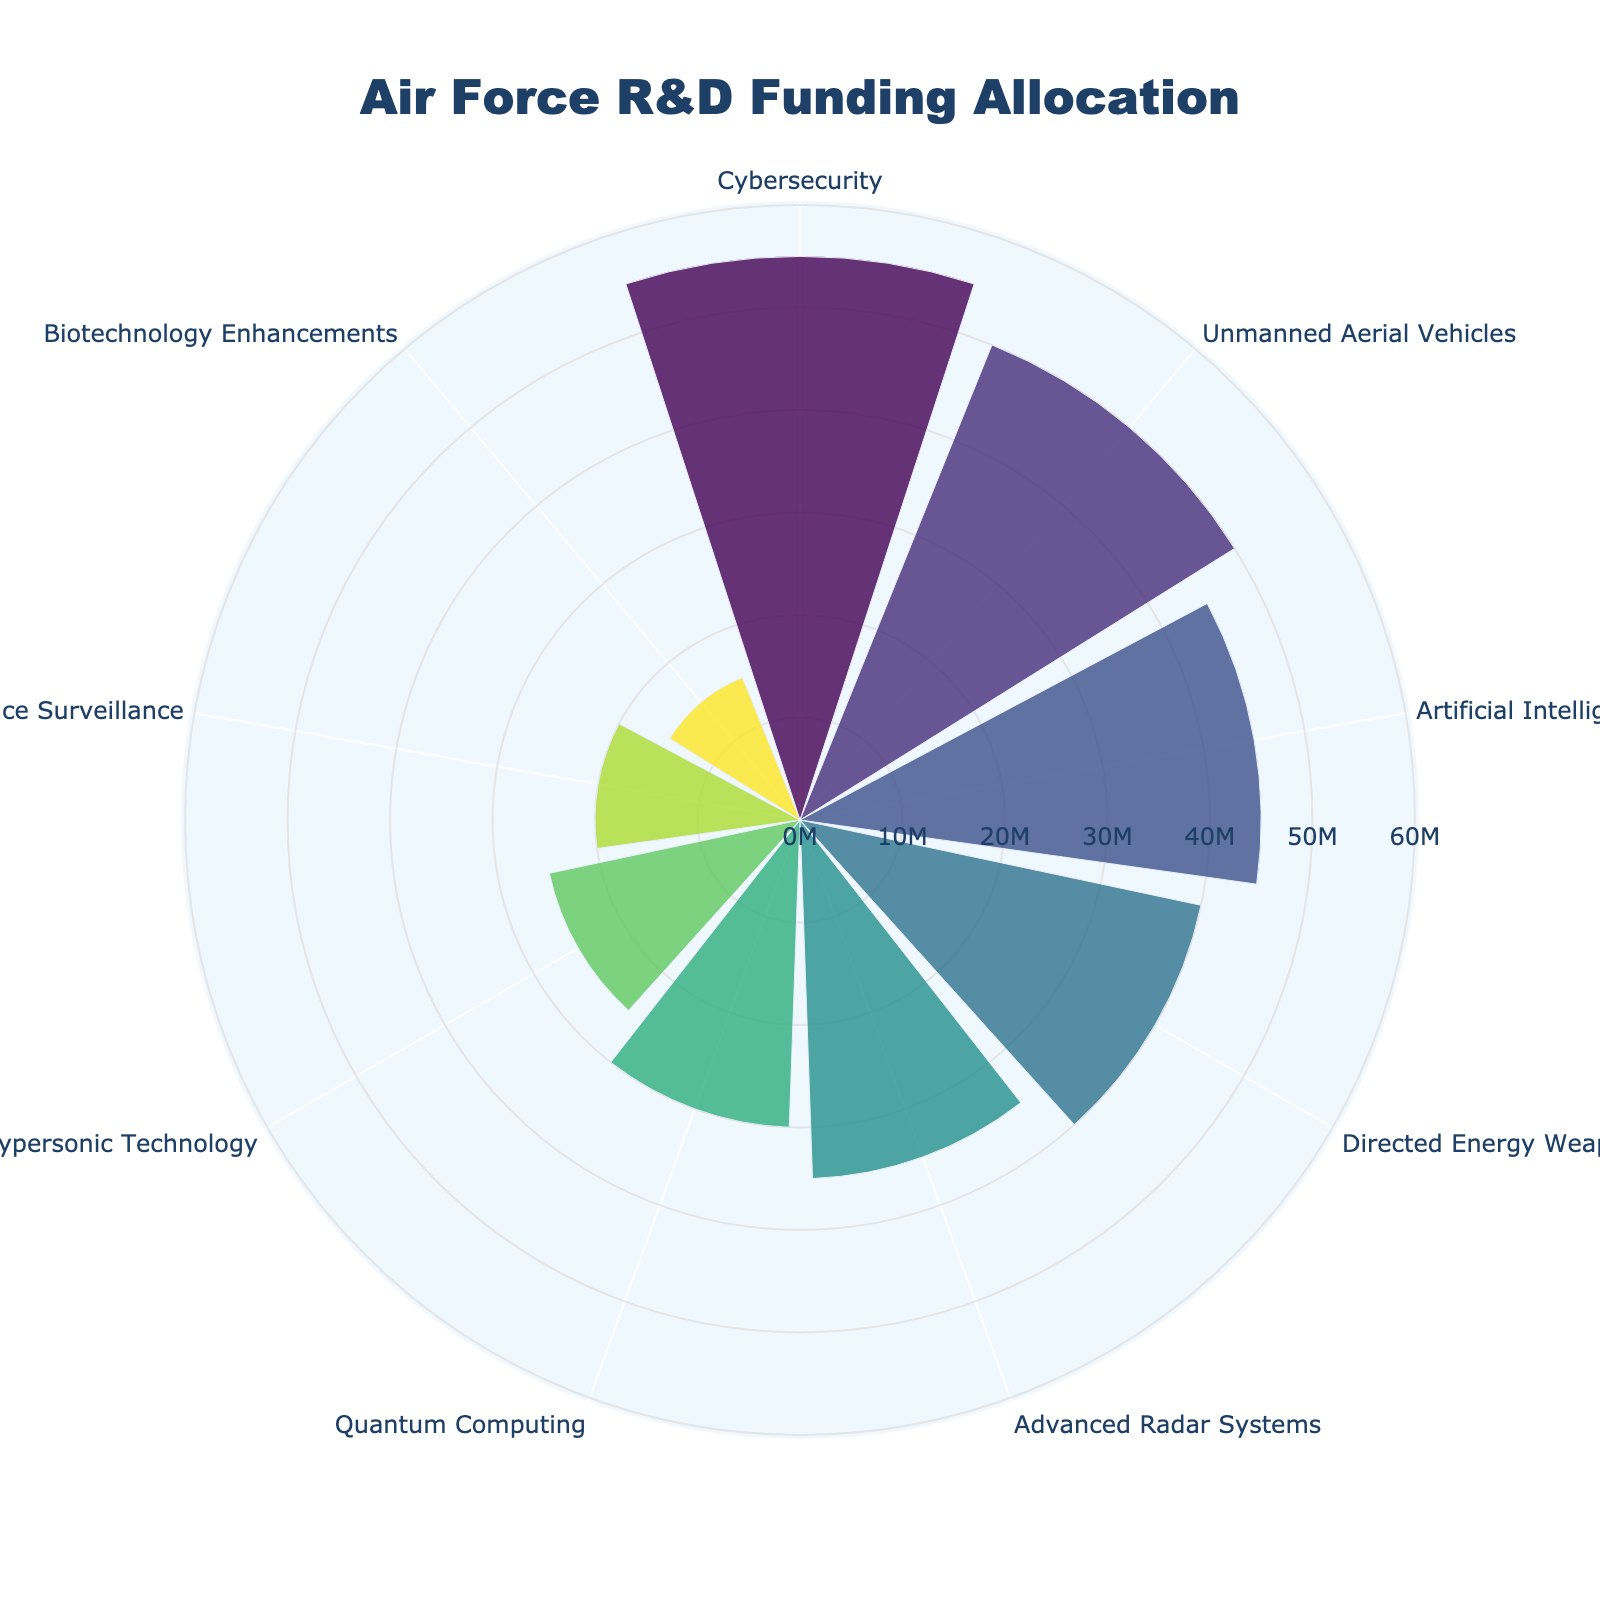Which technology received the highest amount of R&D funding? The polar area chart shows the radial distance of each technology, with the longest bar indicating the highest funding. Cybersecurity has the largest radial distance.
Answer: Cybersecurity What is the total amount of R&D funding allocated across all technologies? Add the funding amounts for all technologies: 45 (AI) + 30 (QC) + 55 (CS) + 25 (HT) + 40 (DEW) + 35 (ARS) + 50 (UAV) + 20 (SS) + 15 (BE) = 315 million USD.
Answer: 315 million USD Which technology received more funding: Artificial Intelligence or Directed Energy Weapons? Compare the radial lengths of the bars for Artificial Intelligence and Directed Energy Weapons. Artificial Intelligence (45 million USD) is slightly longer than Directed Energy Weapons (40 million USD).
Answer: Artificial Intelligence How much more R&D funding did Unmanned Aerial Vehicles receive compared to Space Surveillance? Unmanned Aerial Vehicles received 50 million USD, while Space Surveillance received 20 million USD. The difference is 50 - 20 = 30 million USD.
Answer: 30 million USD What is the average funding amount across all technologies? Total funding is 315 million USD across 9 technologies. Divide the total by the number of technologies: 315 / 9 = 35 million USD.
Answer: 35 million USD Which technology received the least amount of R&D funding? The shortest radial distance in the chart represents the least funding. Biotechnology Enhancements received the least funding.
Answer: Biotechnology Enhancements Between Quantum Computing and Advanced Radar Systems, which technology received a higher allocation of R&D funding? Compare the radial distances for Quantum Computing (30 million USD) and Advanced Radar Systems (35 million USD). Advanced Radar Systems received more funding.
Answer: Advanced Radar Systems What is the combined funding for Hypersonic Technology and Space Surveillance? Sum the funding amounts for Hypersonic Technology (25 million USD) and Space Surveillance (20 million USD). The combined funding is 25 + 20 = 45 million USD.
Answer: 45 million USD What percentage of the total funding is allocated to Cybersecurity? Cybersecurity received 55 million USD out of the total 315 million USD. Calculate the percentage: (55 / 315) * 100 ≈ 17.46%.
Answer: 17.46% Which technological area received exactly 40 million USD in R&D funding? Check the radial distances in the chart to find the bar corresponding to 40 million USD. Directed Energy Weapons received exactly 40 million USD.
Answer: Directed Energy Weapons 